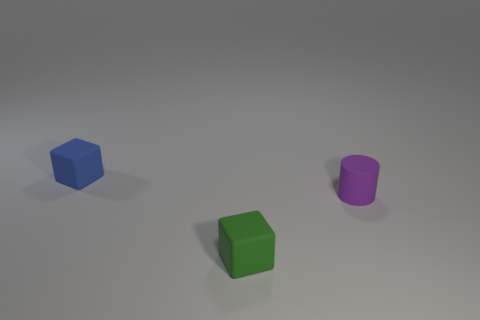How many objects are rubber things that are left of the purple matte thing or green matte spheres?
Keep it short and to the point. 2. Is the number of small green rubber objects less than the number of big red matte things?
Provide a succinct answer. No. There is a small thing that is right of the cube in front of the small rubber block that is behind the purple matte cylinder; what shape is it?
Offer a very short reply. Cylinder. Is there a tiny purple metal block?
Give a very brief answer. No. There is a blue object; is it the same size as the cube that is in front of the tiny blue thing?
Offer a terse response. Yes. Is there a blue matte object in front of the tiny purple rubber cylinder that is right of the tiny green matte cube?
Offer a very short reply. No. What material is the thing that is on the right side of the blue block and behind the tiny green rubber cube?
Provide a succinct answer. Rubber. What is the color of the small object right of the small cube that is right of the rubber object that is behind the cylinder?
Offer a very short reply. Purple. What is the color of the other cube that is the same size as the blue rubber cube?
Give a very brief answer. Green. Is the color of the tiny cylinder the same as the small thing behind the purple object?
Your answer should be compact. No. 